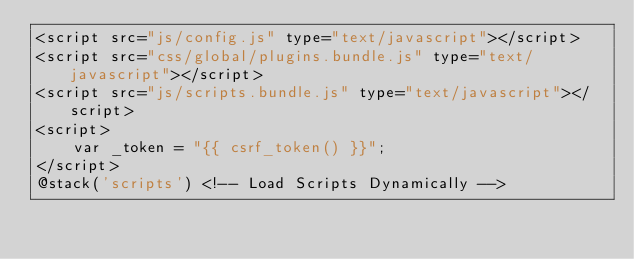Convert code to text. <code><loc_0><loc_0><loc_500><loc_500><_PHP_><script src="js/config.js" type="text/javascript"></script>
<script src="css/global/plugins.bundle.js" type="text/javascript"></script>
<script src="js/scripts.bundle.js" type="text/javascript"></script>
<script>
    var _token = "{{ csrf_token() }}";
</script>
@stack('scripts') <!-- Load Scripts Dynamically -->
</code> 